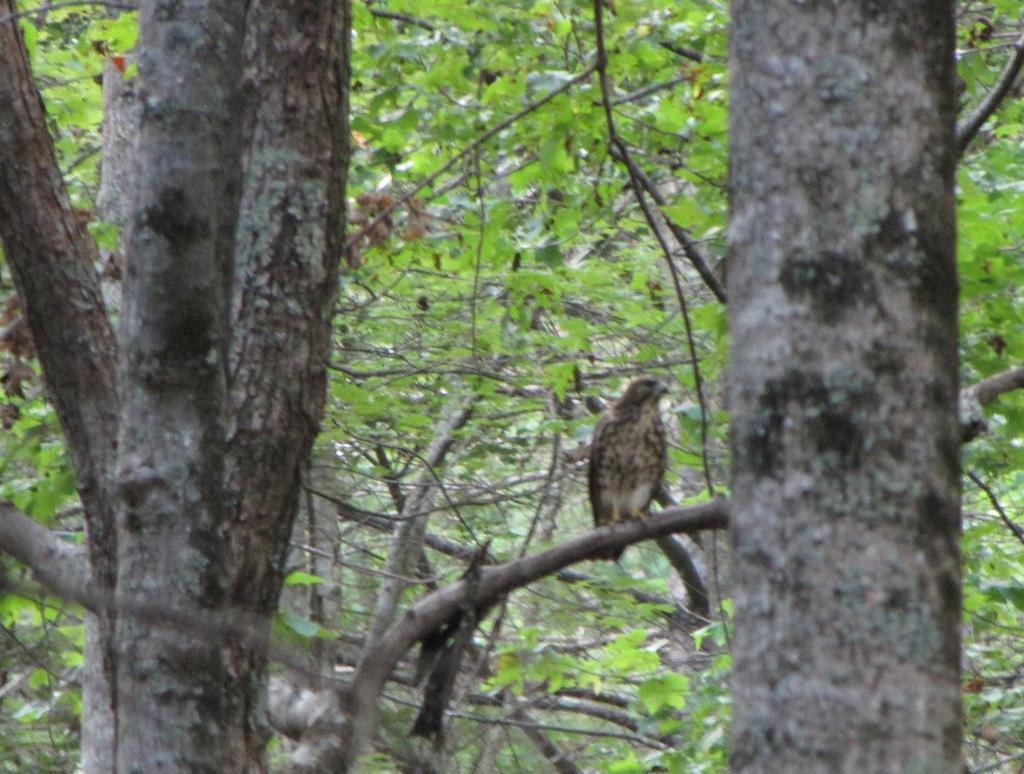Can you describe this image briefly? In this image I can see number of trees and on the right side I can see a bird on a branch. 